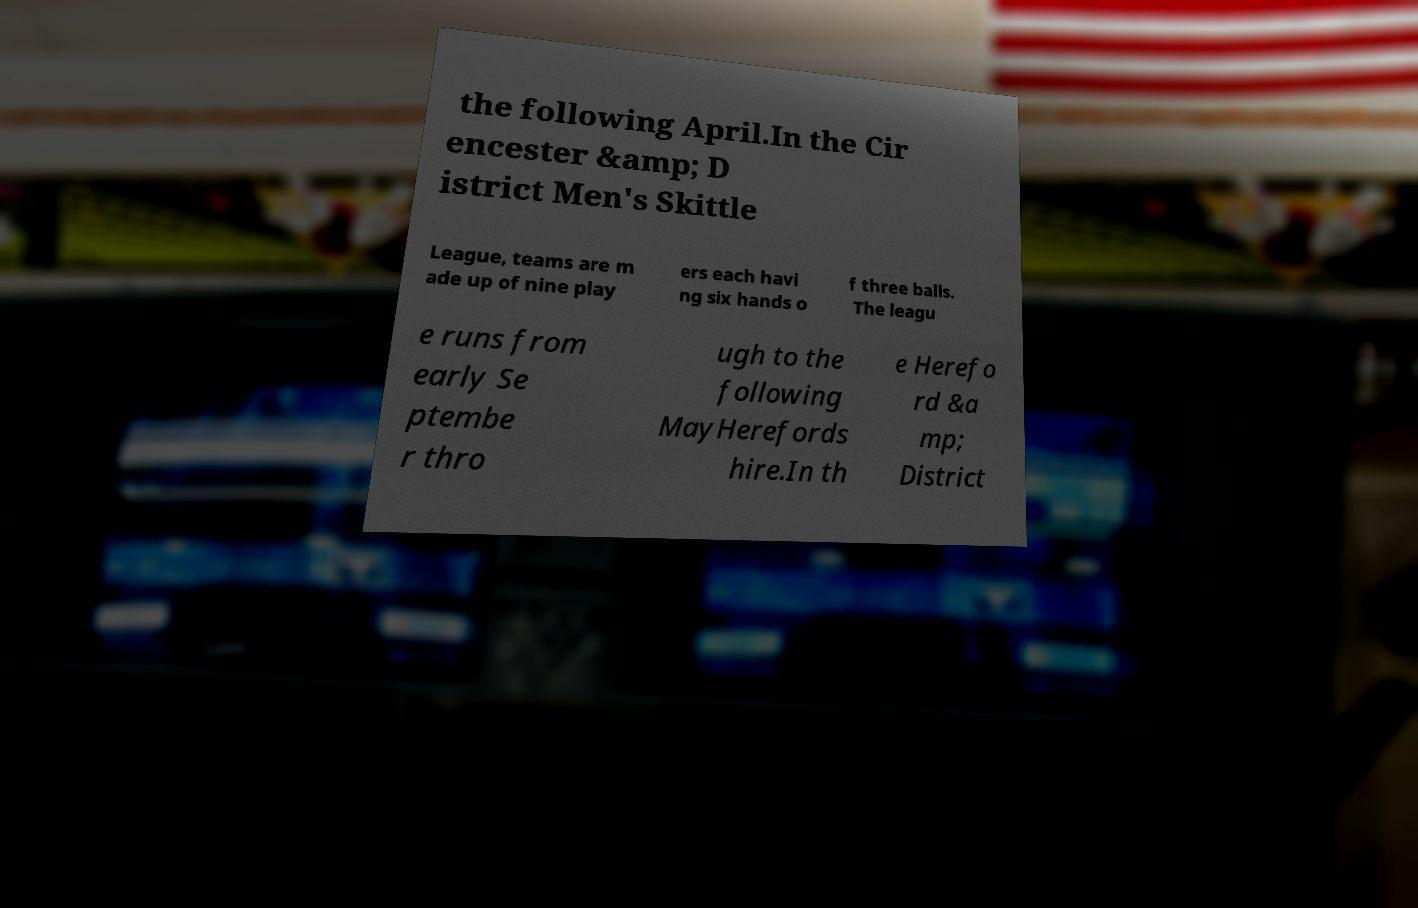I need the written content from this picture converted into text. Can you do that? the following April.In the Cir encester &amp; D istrict Men's Skittle League, teams are m ade up of nine play ers each havi ng six hands o f three balls. The leagu e runs from early Se ptembe r thro ugh to the following MayHerefords hire.In th e Herefo rd &a mp; District 